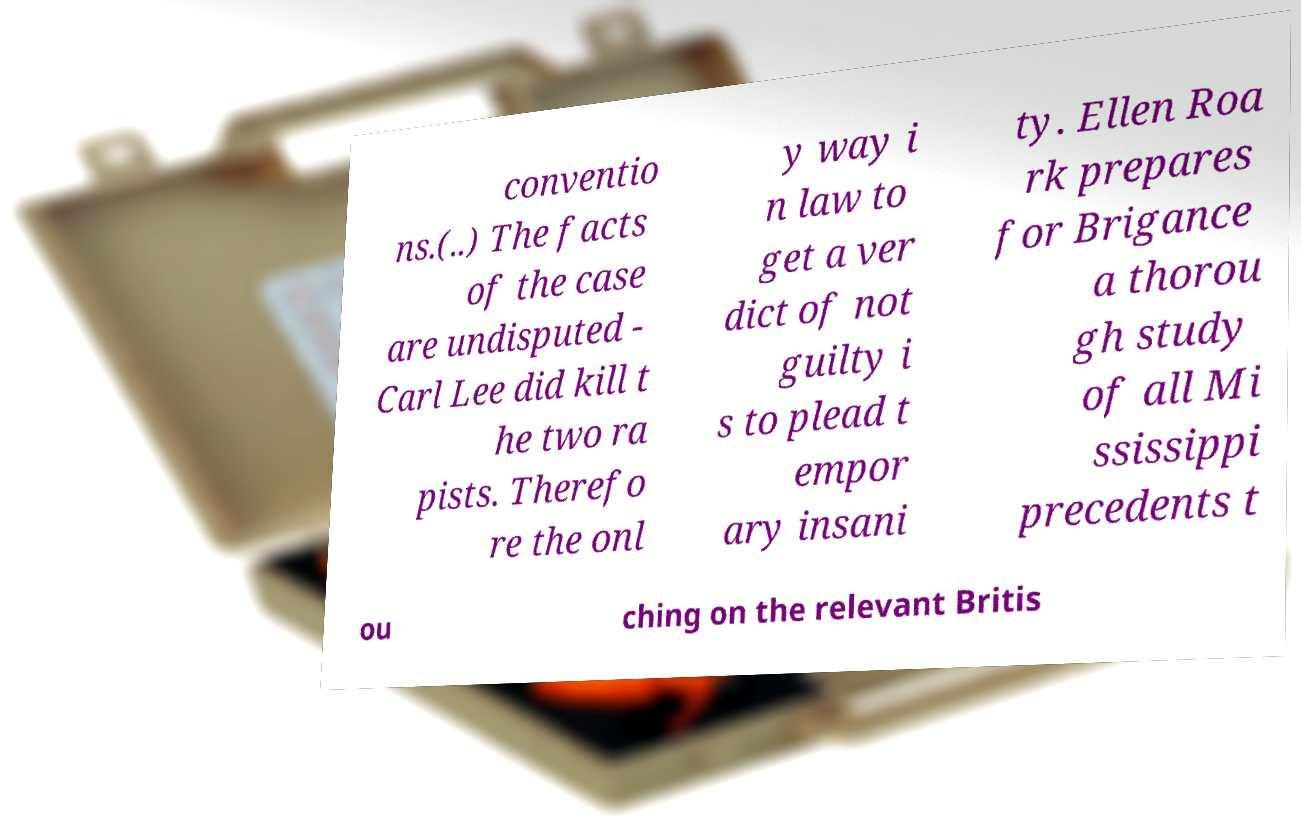Can you accurately transcribe the text from the provided image for me? conventio ns.(..) The facts of the case are undisputed - Carl Lee did kill t he two ra pists. Therefo re the onl y way i n law to get a ver dict of not guilty i s to plead t empor ary insani ty. Ellen Roa rk prepares for Brigance a thorou gh study of all Mi ssissippi precedents t ou ching on the relevant Britis 